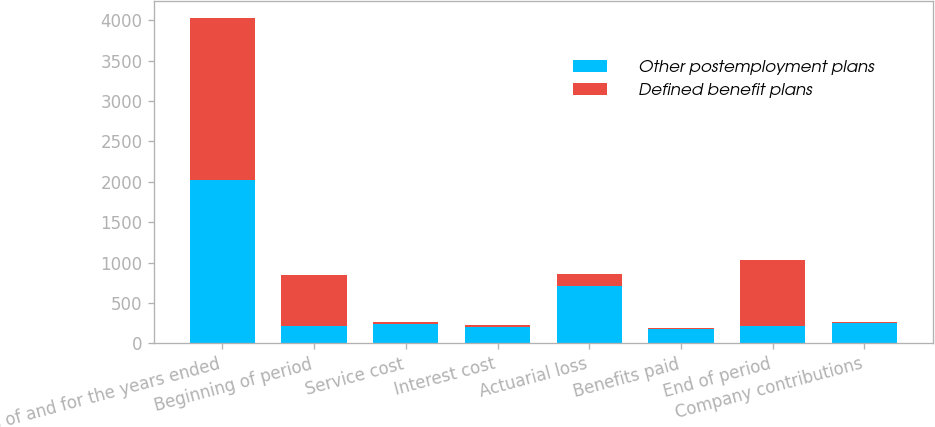Convert chart to OTSL. <chart><loc_0><loc_0><loc_500><loc_500><stacked_bar_chart><ecel><fcel>as of and for the years ended<fcel>Beginning of period<fcel>Service cost<fcel>Interest cost<fcel>Actuarial loss<fcel>Benefits paid<fcel>End of period<fcel>Company contributions<nl><fcel>Other postemployment plans<fcel>2017<fcel>220<fcel>236<fcel>204<fcel>714<fcel>173<fcel>220<fcel>246<nl><fcel>Defined benefit plans<fcel>2017<fcel>627<fcel>26<fcel>24<fcel>149<fcel>15<fcel>813<fcel>15<nl></chart> 